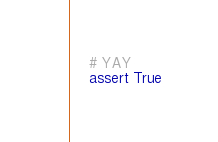<code> <loc_0><loc_0><loc_500><loc_500><_Python_>    # YAY
    assert True
</code> 